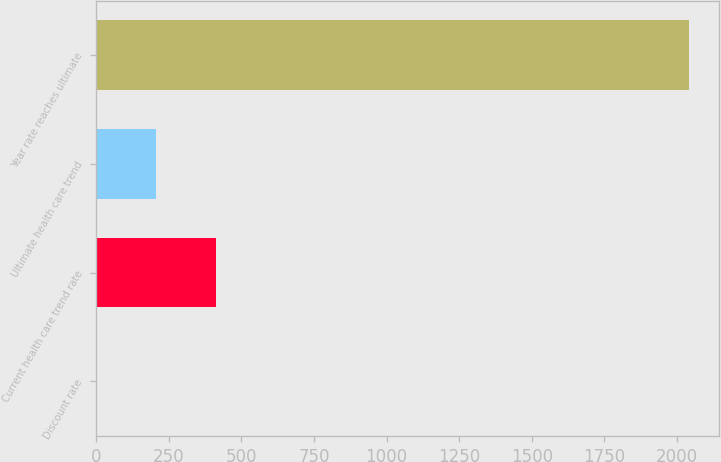Convert chart to OTSL. <chart><loc_0><loc_0><loc_500><loc_500><bar_chart><fcel>Discount rate<fcel>Current health care trend rate<fcel>Ultimate health care trend<fcel>Year rate reaches ultimate<nl><fcel>3.6<fcel>411.28<fcel>207.44<fcel>2042<nl></chart> 